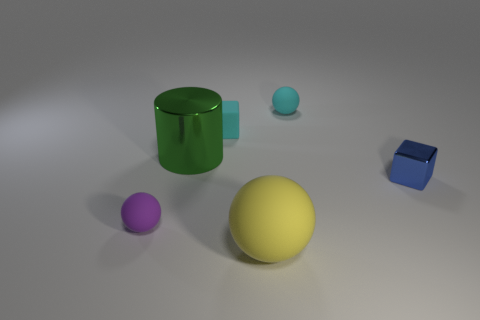Subtract all cyan spheres. How many spheres are left? 2 Add 3 matte things. How many objects exist? 9 Subtract 3 balls. How many balls are left? 0 Add 5 blue things. How many blue things exist? 6 Subtract all cyan spheres. How many spheres are left? 2 Subtract 0 gray spheres. How many objects are left? 6 Subtract all blocks. How many objects are left? 4 Subtract all red balls. Subtract all red blocks. How many balls are left? 3 Subtract all blue spheres. How many blue cubes are left? 1 Subtract all cyan balls. Subtract all tiny balls. How many objects are left? 3 